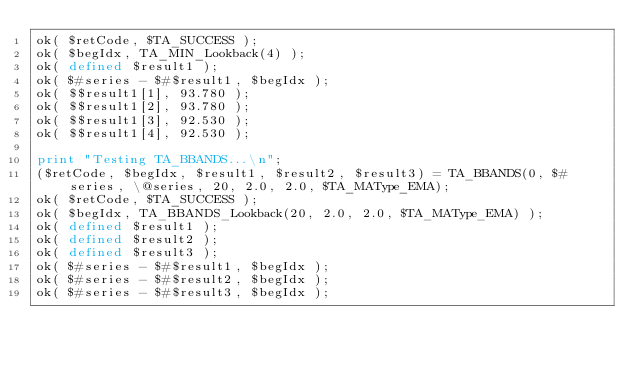<code> <loc_0><loc_0><loc_500><loc_500><_Perl_>ok( $retCode, $TA_SUCCESS );
ok( $begIdx, TA_MIN_Lookback(4) );
ok( defined $result1 );
ok( $#series - $#$result1, $begIdx );
ok( $$result1[1], 93.780 );
ok( $$result1[2], 93.780 );
ok( $$result1[3], 92.530 );
ok( $$result1[4], 92.530 );

print "Testing TA_BBANDS...\n";
($retCode, $begIdx, $result1, $result2, $result3) = TA_BBANDS(0, $#series, \@series, 20, 2.0, 2.0, $TA_MAType_EMA);
ok( $retCode, $TA_SUCCESS );
ok( $begIdx, TA_BBANDS_Lookback(20, 2.0, 2.0, $TA_MAType_EMA) );
ok( defined $result1 );
ok( defined $result2 );
ok( defined $result3 );
ok( $#series - $#$result1, $begIdx );
ok( $#series - $#$result2, $begIdx );
ok( $#series - $#$result3, $begIdx );</code> 